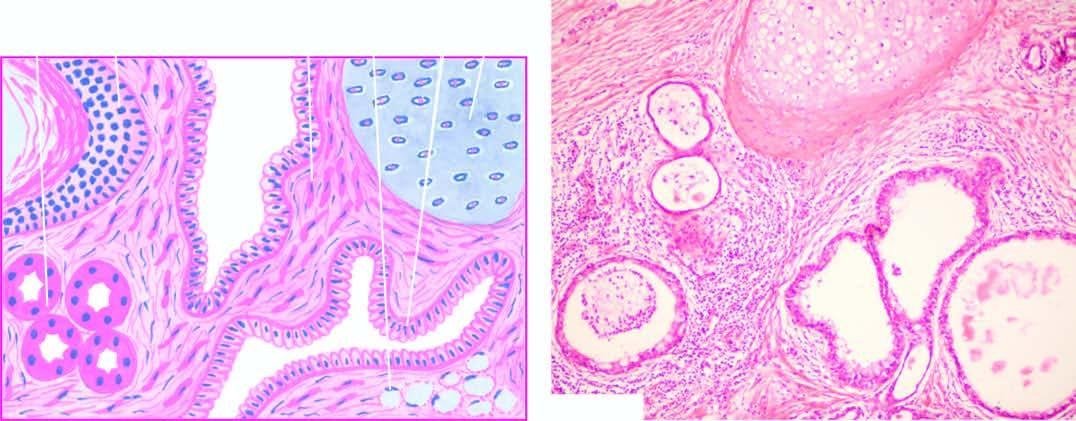what shows characteristic lining of the cyst wall by epidermis and its appendages?
Answer the question using a single word or phrase. Microscopy 